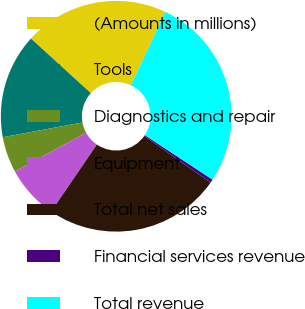Convert chart to OTSL. <chart><loc_0><loc_0><loc_500><loc_500><pie_chart><fcel>(Amounts in millions)<fcel>Tools<fcel>Diagnostics and repair<fcel>Equipment<fcel>Total net sales<fcel>Financial services revenue<fcel>Total revenue<nl><fcel>20.25%<fcel>14.67%<fcel>5.04%<fcel>7.52%<fcel>24.78%<fcel>0.49%<fcel>27.26%<nl></chart> 